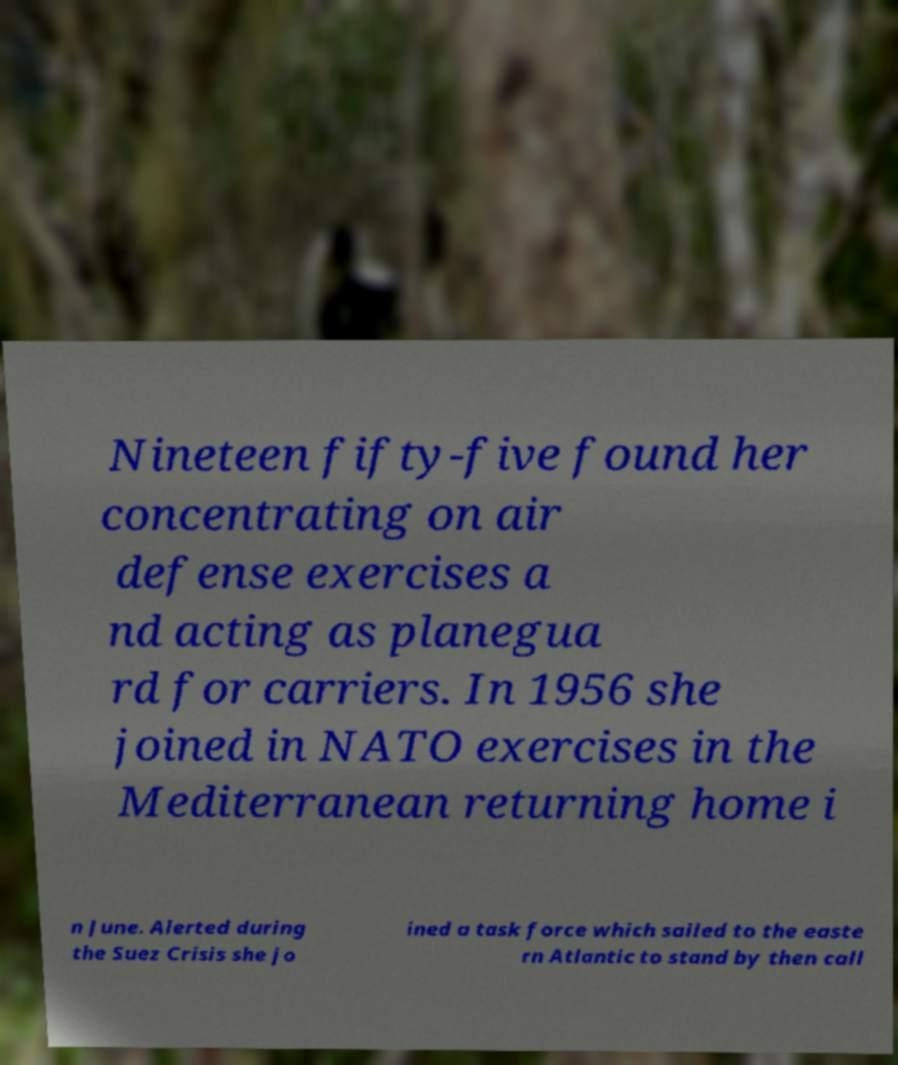For documentation purposes, I need the text within this image transcribed. Could you provide that? Nineteen fifty-five found her concentrating on air defense exercises a nd acting as planegua rd for carriers. In 1956 she joined in NATO exercises in the Mediterranean returning home i n June. Alerted during the Suez Crisis she jo ined a task force which sailed to the easte rn Atlantic to stand by then call 